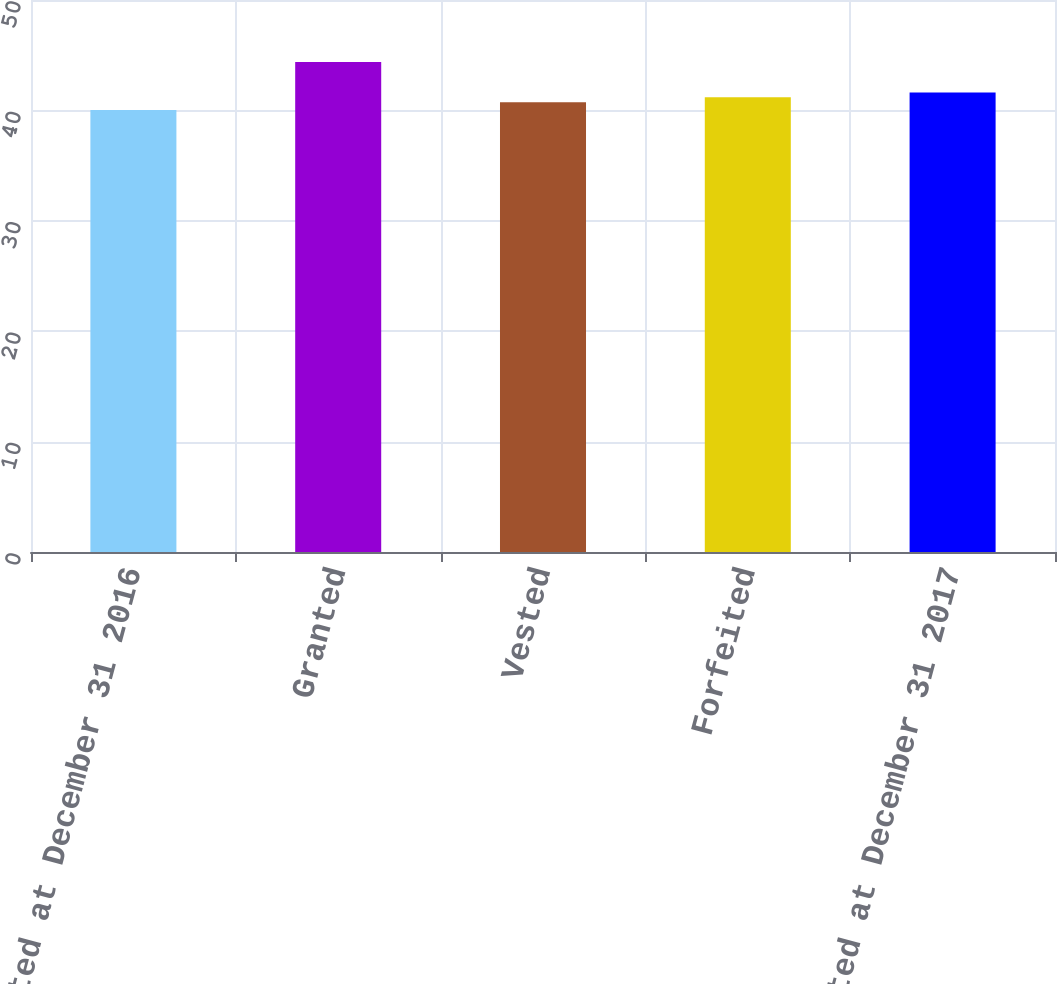<chart> <loc_0><loc_0><loc_500><loc_500><bar_chart><fcel>Non-vested at December 31 2016<fcel>Granted<fcel>Vested<fcel>Forfeited<fcel>Non-vested at December 31 2017<nl><fcel>40.03<fcel>44.38<fcel>40.74<fcel>41.18<fcel>41.62<nl></chart> 